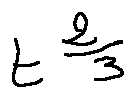Convert formula to latex. <formula><loc_0><loc_0><loc_500><loc_500>t ^ { \frac { 2 } { 3 } }</formula> 